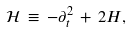<formula> <loc_0><loc_0><loc_500><loc_500>{ \mathcal { H } } \, \equiv \, - \partial _ { t } ^ { 2 } \, + \, 2 H ,</formula> 